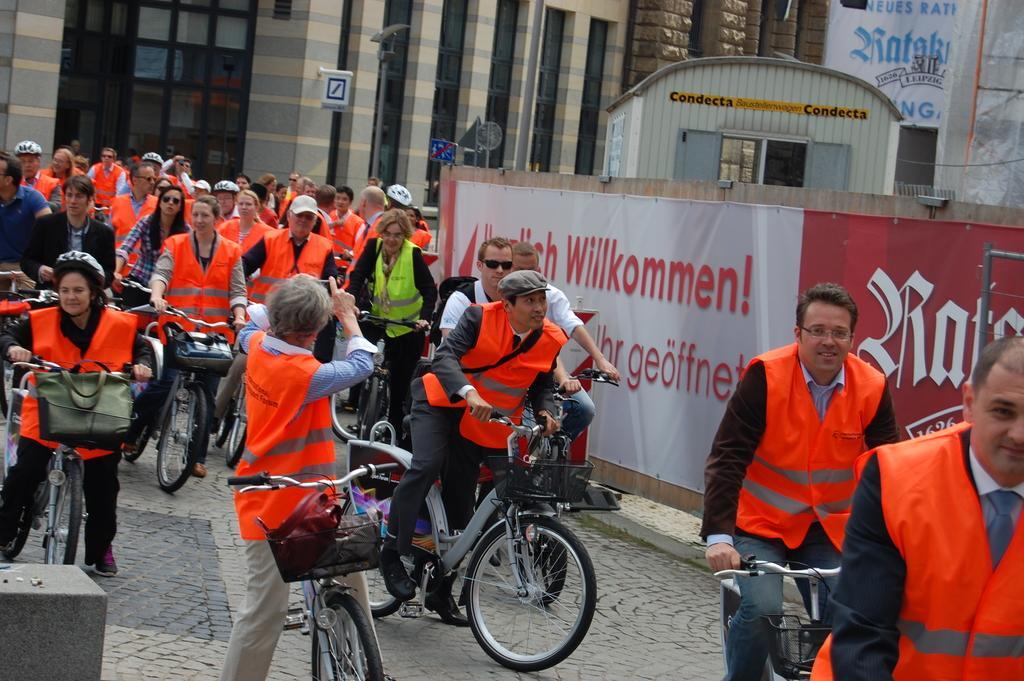Could you give a brief overview of what you see in this image? In this image I can see some people on the bicycles and beside there is a board and also we can see some buildings behind them. 